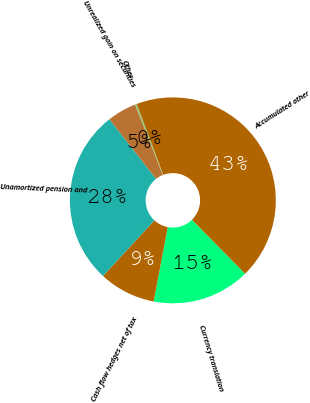Convert chart to OTSL. <chart><loc_0><loc_0><loc_500><loc_500><pie_chart><fcel>Currency translation<fcel>Cash flow hedges net of tax<fcel>Unamortized pension and<fcel>Unrealized gain on securities<fcel>Other<fcel>Accumulated other<nl><fcel>15.36%<fcel>8.89%<fcel>27.56%<fcel>4.59%<fcel>0.28%<fcel>43.32%<nl></chart> 